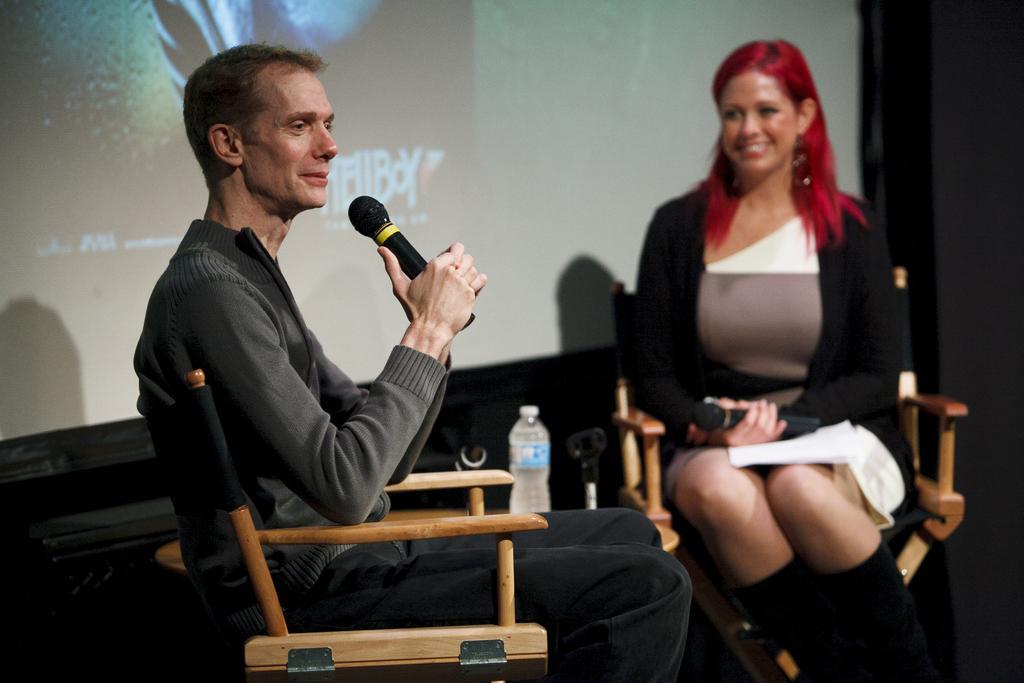Describe this image in one or two sentences. In the image there is a man sat and talking on mic,beside him there is a woman sat looking at him on a stage. 